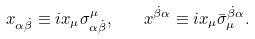<formula> <loc_0><loc_0><loc_500><loc_500>x _ { \alpha \dot { \beta } } \equiv i x _ { \mu } \sigma ^ { \mu } _ { \alpha \dot { \beta } } , \quad x ^ { \dot { \beta } \alpha } \equiv i x _ { \mu } \bar { \sigma } _ { \mu } ^ { \dot { \beta } \alpha } .</formula> 